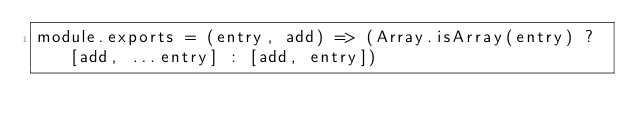<code> <loc_0><loc_0><loc_500><loc_500><_JavaScript_>module.exports = (entry, add) => (Array.isArray(entry) ? [add, ...entry] : [add, entry])
</code> 